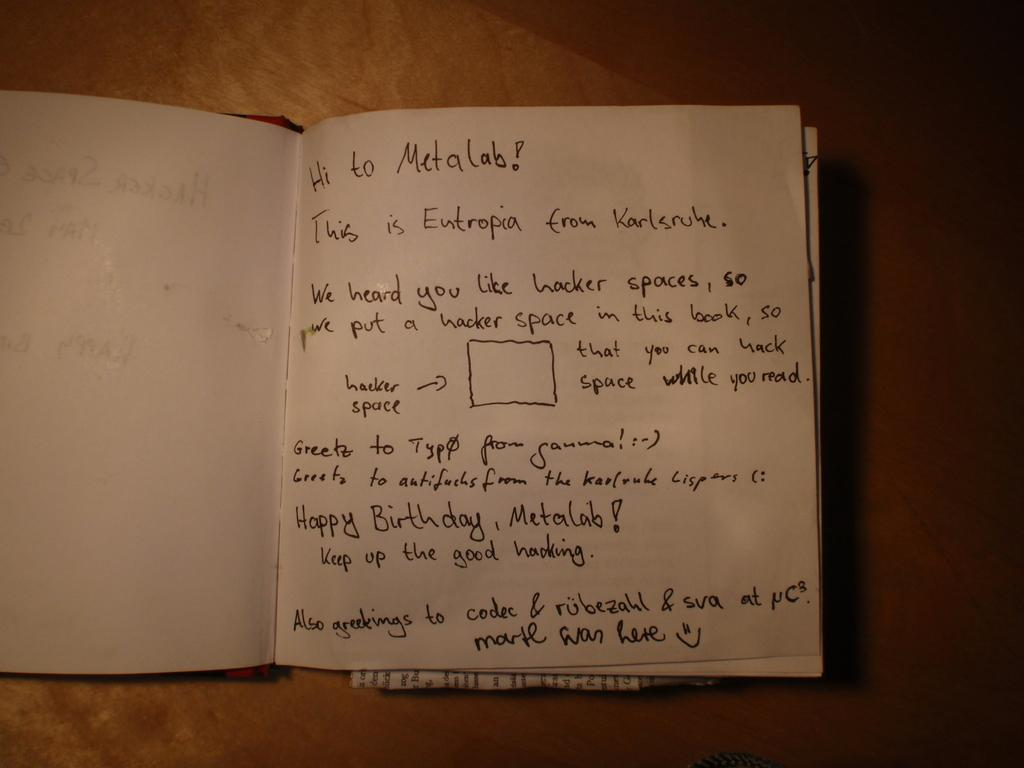<image>
Relay a brief, clear account of the picture shown. a book with white paper that says metalab in it 